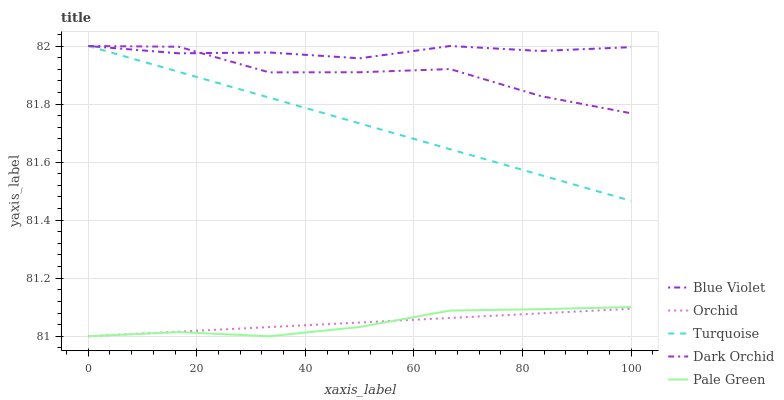Does Pale Green have the minimum area under the curve?
Answer yes or no. Yes. Does Blue Violet have the maximum area under the curve?
Answer yes or no. Yes. Does Dark Orchid have the minimum area under the curve?
Answer yes or no. No. Does Dark Orchid have the maximum area under the curve?
Answer yes or no. No. Is Turquoise the smoothest?
Answer yes or no. Yes. Is Dark Orchid the roughest?
Answer yes or no. Yes. Is Pale Green the smoothest?
Answer yes or no. No. Is Pale Green the roughest?
Answer yes or no. No. Does Pale Green have the lowest value?
Answer yes or no. Yes. Does Dark Orchid have the lowest value?
Answer yes or no. No. Does Blue Violet have the highest value?
Answer yes or no. Yes. Does Pale Green have the highest value?
Answer yes or no. No. Is Pale Green less than Turquoise?
Answer yes or no. Yes. Is Dark Orchid greater than Pale Green?
Answer yes or no. Yes. Does Turquoise intersect Dark Orchid?
Answer yes or no. Yes. Is Turquoise less than Dark Orchid?
Answer yes or no. No. Is Turquoise greater than Dark Orchid?
Answer yes or no. No. Does Pale Green intersect Turquoise?
Answer yes or no. No. 